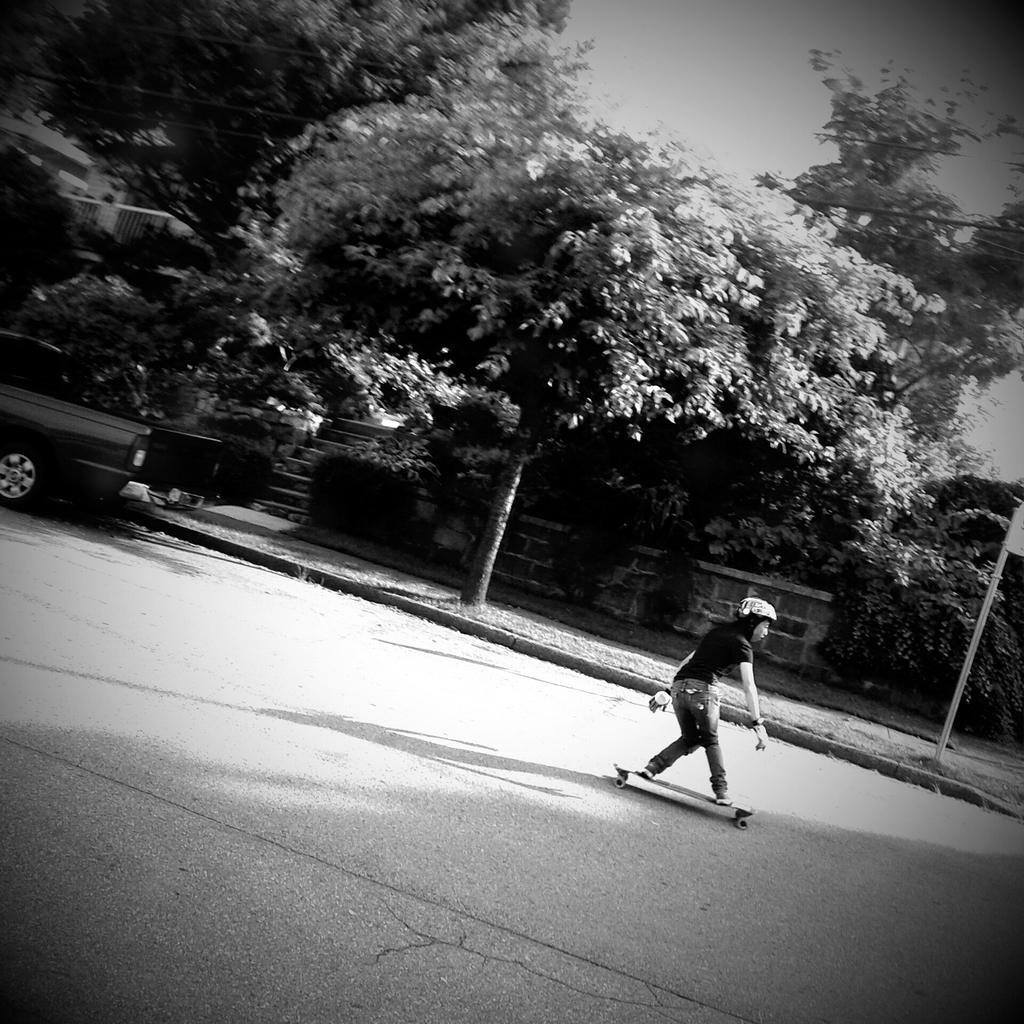Please provide a concise description of this image. At the bottom of the image a woman is doing skating on road. Behind her there are some trees and vehicle and poles. At the top of the image there is sky. 